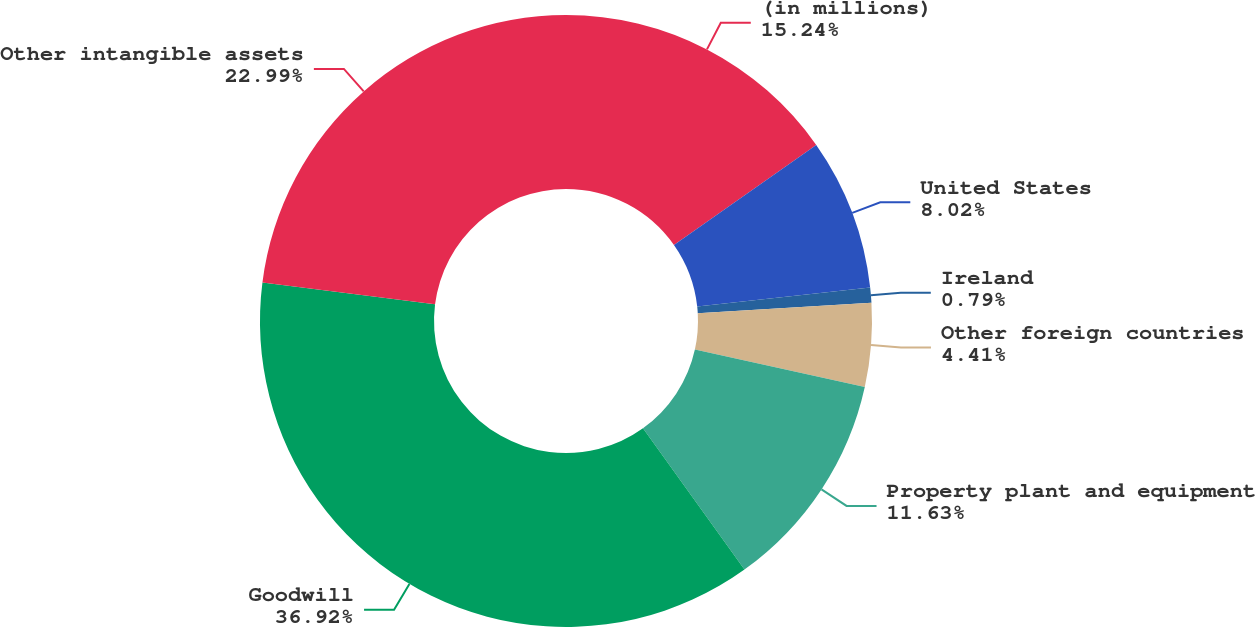Convert chart. <chart><loc_0><loc_0><loc_500><loc_500><pie_chart><fcel>(in millions)<fcel>United States<fcel>Ireland<fcel>Other foreign countries<fcel>Property plant and equipment<fcel>Goodwill<fcel>Other intangible assets<nl><fcel>15.24%<fcel>8.02%<fcel>0.79%<fcel>4.41%<fcel>11.63%<fcel>36.92%<fcel>22.99%<nl></chart> 